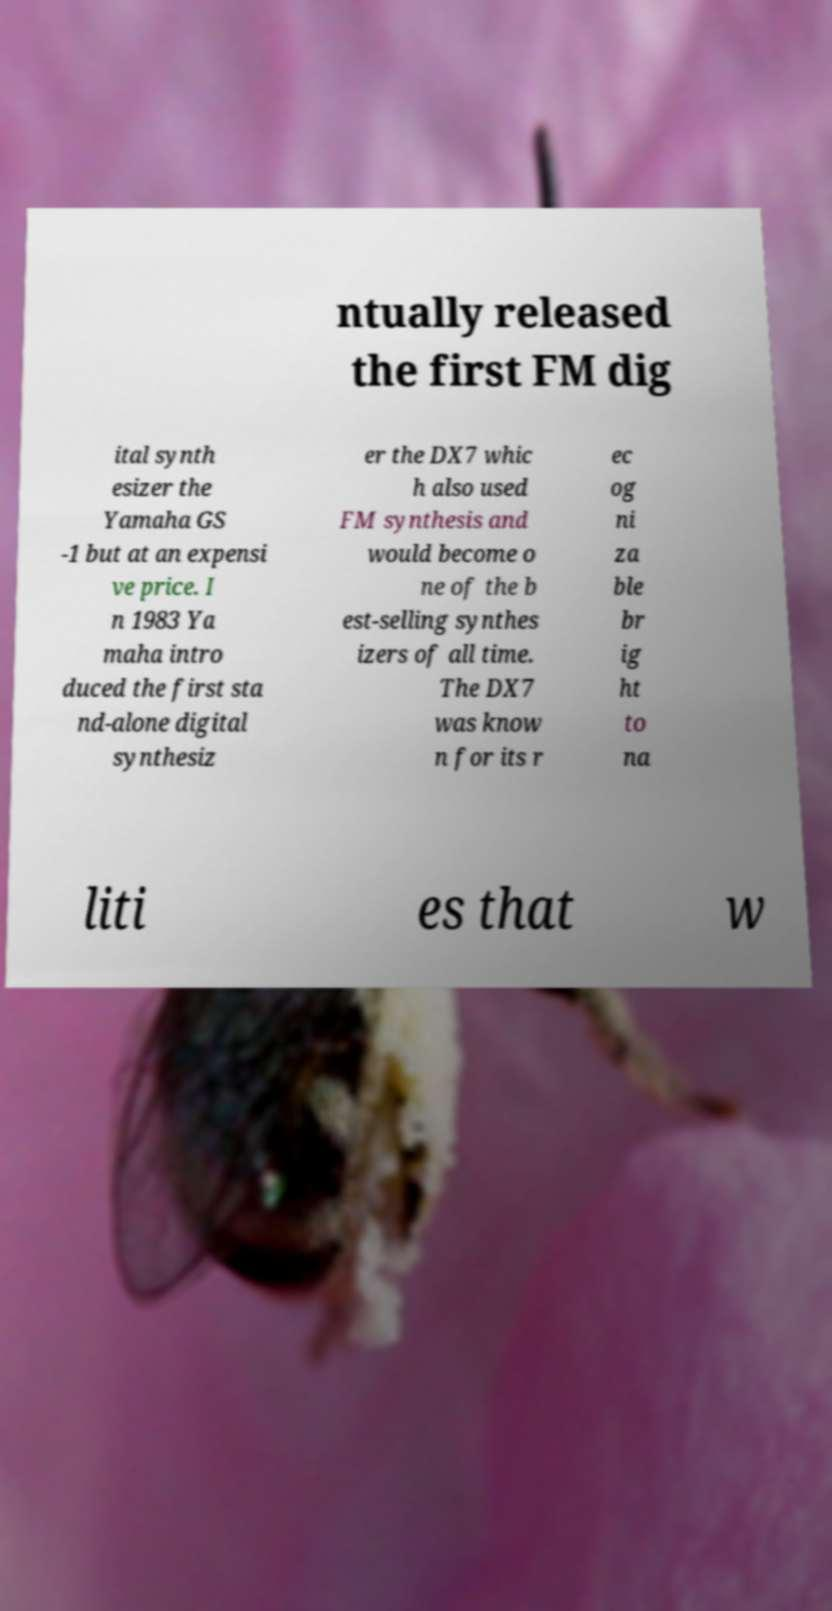Can you read and provide the text displayed in the image?This photo seems to have some interesting text. Can you extract and type it out for me? ntually released the first FM dig ital synth esizer the Yamaha GS -1 but at an expensi ve price. I n 1983 Ya maha intro duced the first sta nd-alone digital synthesiz er the DX7 whic h also used FM synthesis and would become o ne of the b est-selling synthes izers of all time. The DX7 was know n for its r ec og ni za ble br ig ht to na liti es that w 